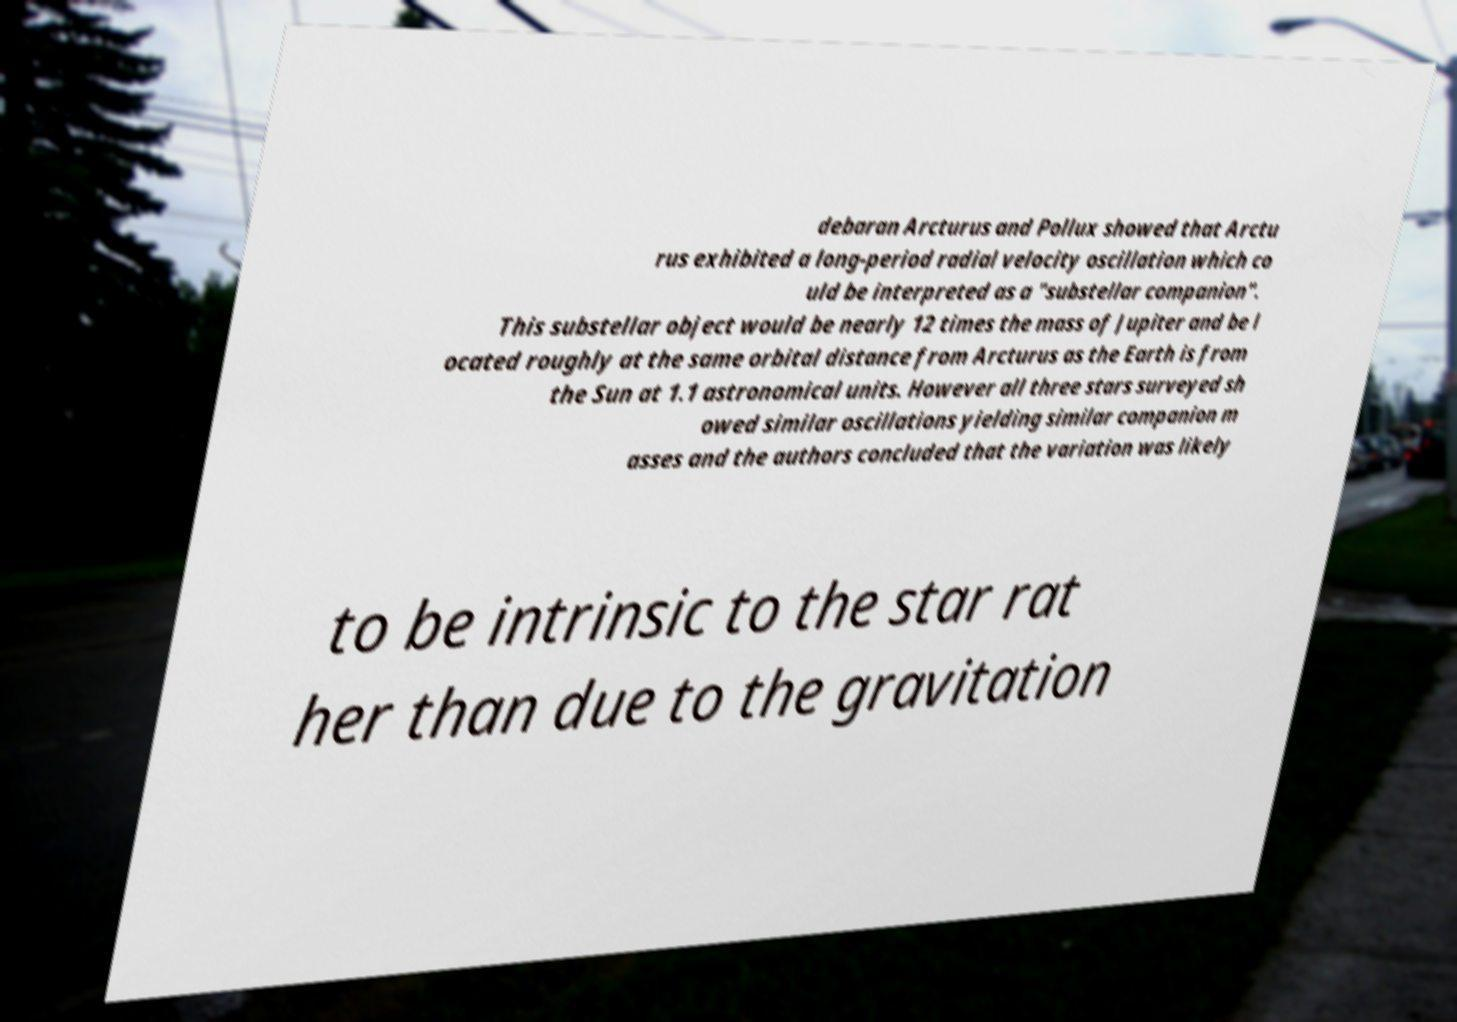There's text embedded in this image that I need extracted. Can you transcribe it verbatim? debaran Arcturus and Pollux showed that Arctu rus exhibited a long-period radial velocity oscillation which co uld be interpreted as a "substellar companion". This substellar object would be nearly 12 times the mass of Jupiter and be l ocated roughly at the same orbital distance from Arcturus as the Earth is from the Sun at 1.1 astronomical units. However all three stars surveyed sh owed similar oscillations yielding similar companion m asses and the authors concluded that the variation was likely to be intrinsic to the star rat her than due to the gravitation 